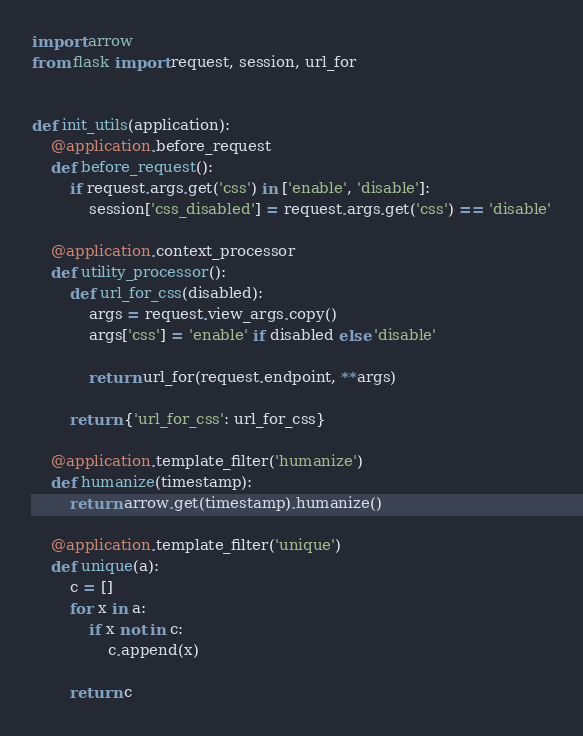Convert code to text. <code><loc_0><loc_0><loc_500><loc_500><_Python_>import arrow
from flask import request, session, url_for


def init_utils(application):
    @application.before_request
    def before_request():
        if request.args.get('css') in ['enable', 'disable']:
            session['css_disabled'] = request.args.get('css') == 'disable'

    @application.context_processor
    def utility_processor():
        def url_for_css(disabled):
            args = request.view_args.copy()
            args['css'] = 'enable' if disabled else 'disable'

            return url_for(request.endpoint, **args)

        return {'url_for_css': url_for_css}

    @application.template_filter('humanize')
    def humanize(timestamp):
        return arrow.get(timestamp).humanize()

    @application.template_filter('unique')
    def unique(a):
        c = []
        for x in a:
            if x not in c:
                c.append(x)

        return c
</code> 